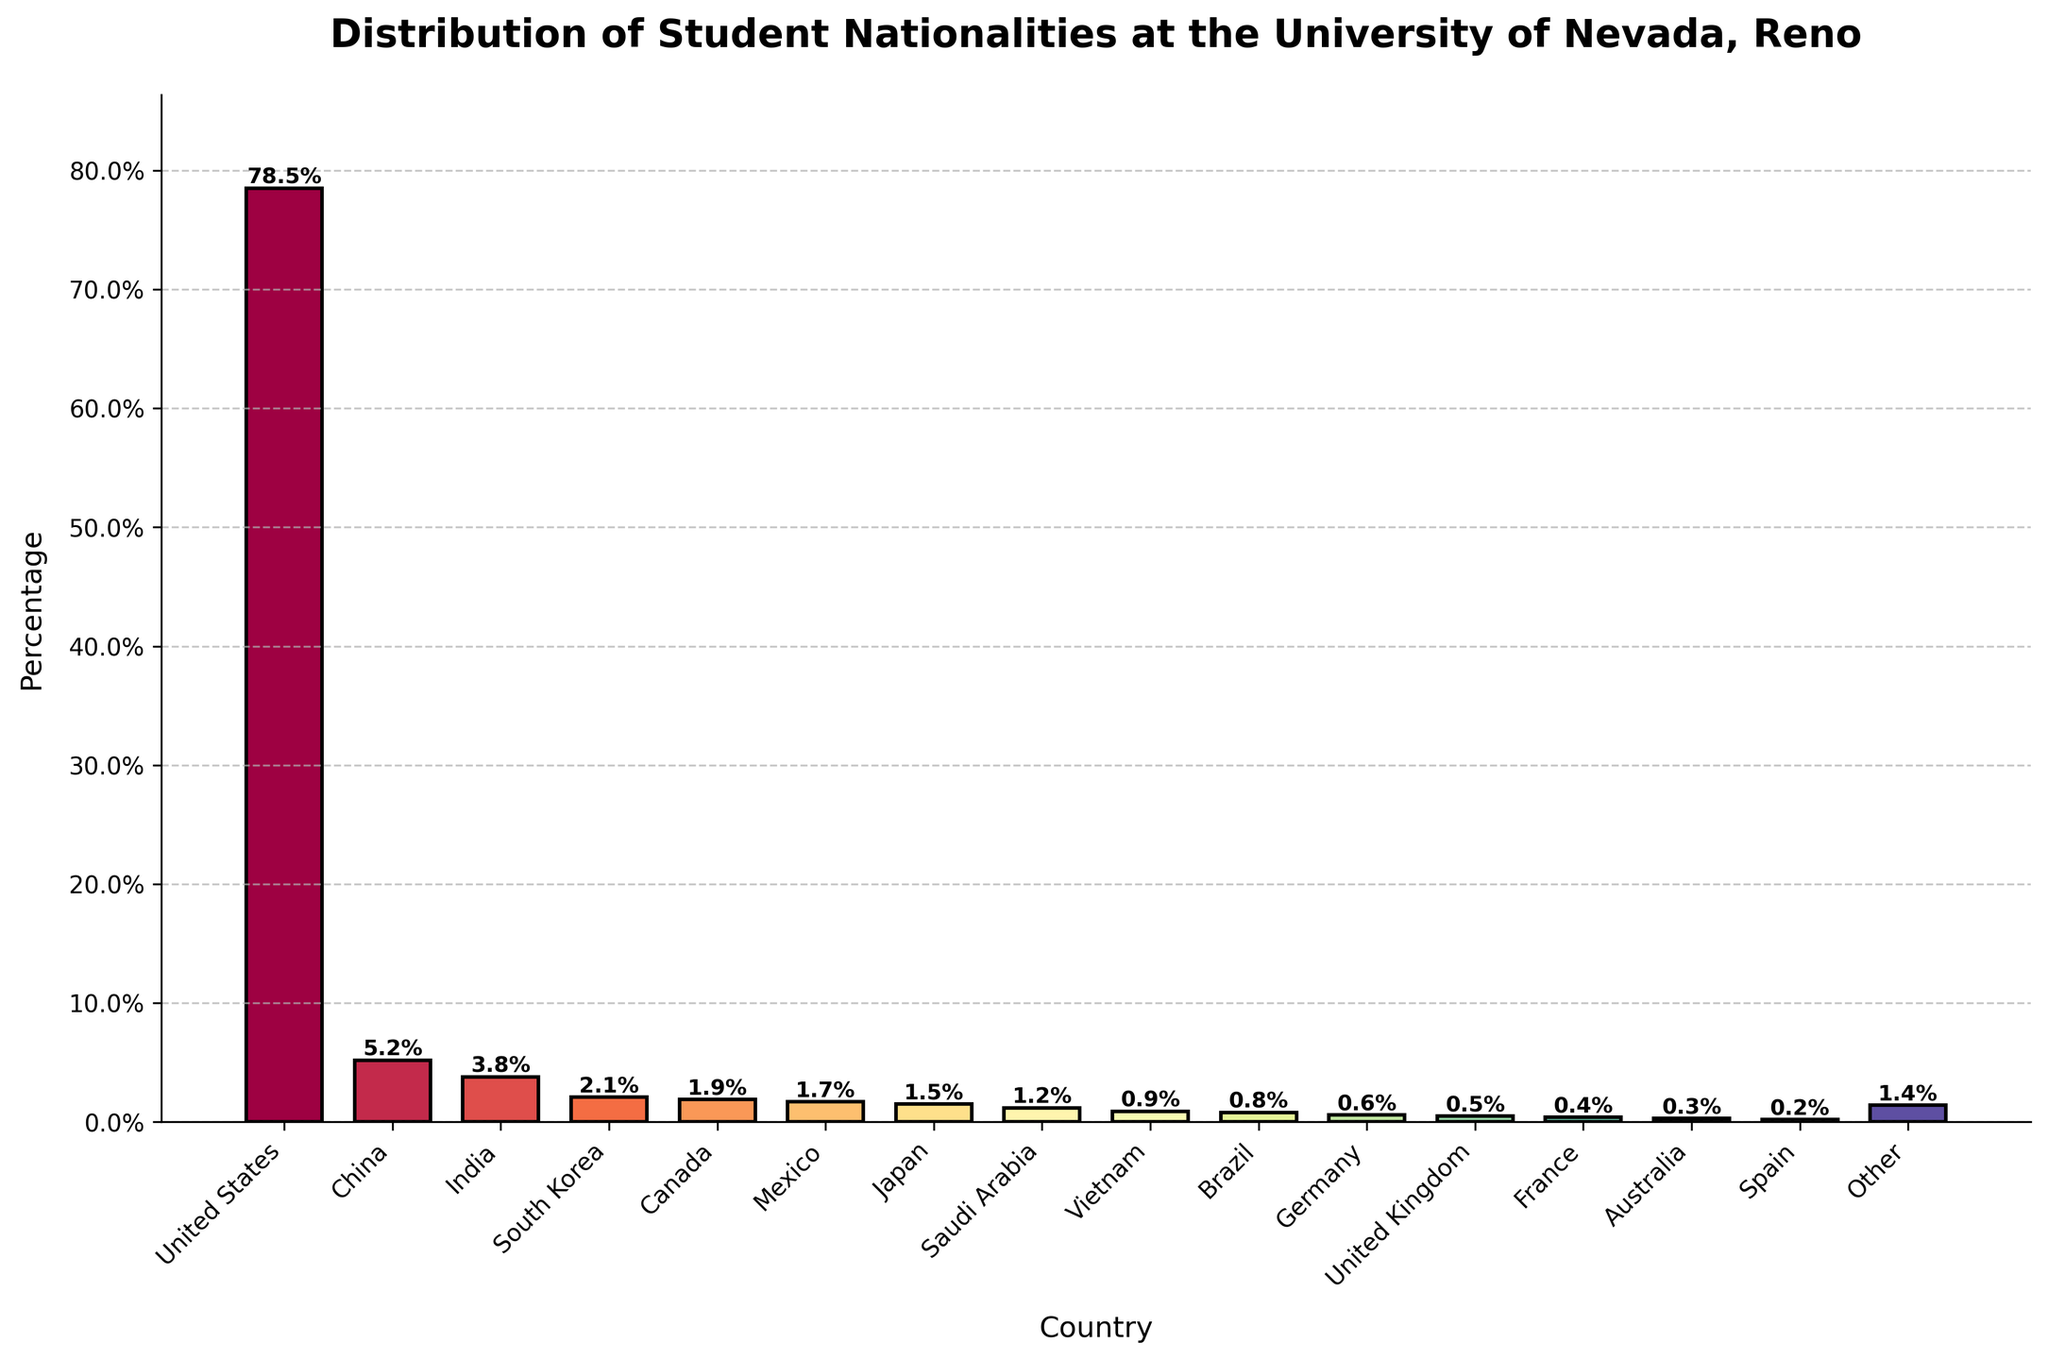Which country has the highest percentage of students at the University of Nevada, Reno? The tallest bar represents the country with the highest percentage of students. The bar labeled "United States" is the tallest.
Answer: United States Which two countries have the smallest percentages of students, and what are these percentages? The shortest bars represent the countries with the smallest percentages. The bars labeled "Spain" and "Australia" are the shortest. Their percentages are 0.2% and 0.3% respectively.
Answer: Spain (0.2%), Australia (0.3%) What is the total percentage of students from China, India, and South Korea? Sum the percentages of the bars labeled "China," "India," and "South Korea." These are 5.2%, 3.8%, and 2.1% respectively. 5.2% + 3.8% + 2.1% = 11.1%.
Answer: 11.1% Is the percentage of students from Mexico higher or lower than that from Canada, and by how much? Compare the heights of the bars labeled "Mexico" and "Canada." The percentage of students from Mexico (1.7%) is lower than that from Canada (1.9%). The difference is 1.9% - 1.7% = 0.2%.
Answer: Lower by 0.2% Which country has a percentage closest to 1%? Identify the bar with a height closest to 1%. The bar labeled "Vietnam" is closest to 1% at 0.9%.
Answer: Vietnam What is the combined percentage of students from the top three countries? Sum the percentages of the top three countries. These are the United States (78.5%), China (5.2%), and India (3.8%). 78.5% + 5.2% + 3.8% = 87.5%.
Answer: 87.5% How many countries have a student percentage of less than 1.0%? Count the bars whose heights are less than 1.0%. The countries are Vietnam, Brazil, Germany, United Kingdom, France, Australia, and Spain. This totals to 7 countries.
Answer: 7 What is the average percentage of students from countries other than the United States? Exclude the United States percentage (78.5%). Sum the remaining percentages and divide by the number of these countries. (100 - 78.5)% = 21.5%. There are 15 countries other than the United States, so the average is 21.5 / 15 = 1.43%.
Answer: 1.43% Which country’s bar is colored towards the end of the color spectrum (more red or blue)? Look at the bars colored at the extreme end of the spectrum (darker red or blue). The bar for "Spain" is colored towards the end and is a dark blue.
Answer: Spain 